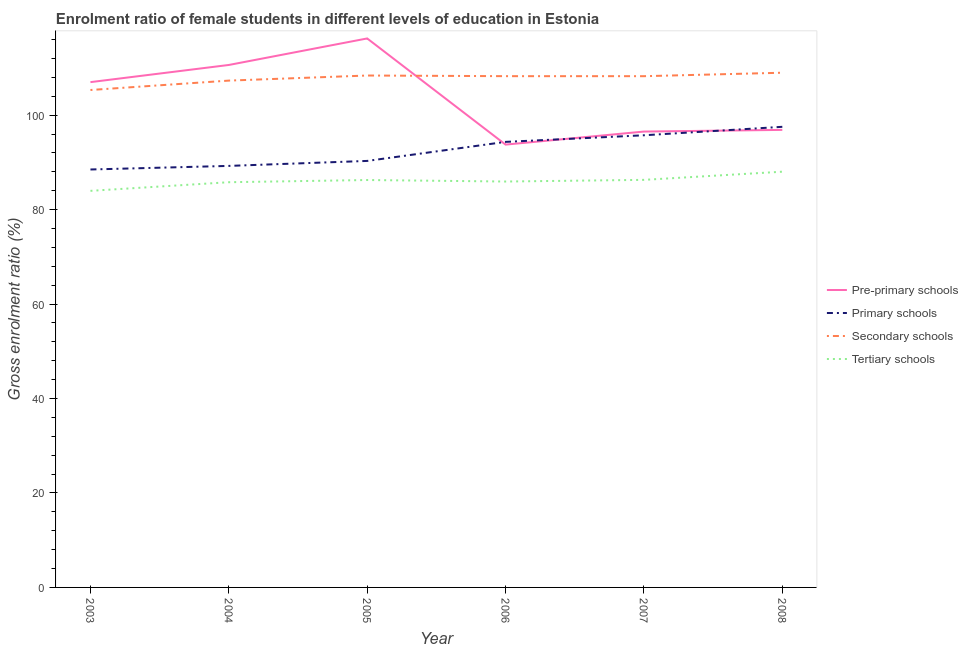How many different coloured lines are there?
Give a very brief answer. 4. Does the line corresponding to gross enrolment ratio(male) in secondary schools intersect with the line corresponding to gross enrolment ratio(male) in primary schools?
Offer a very short reply. No. What is the gross enrolment ratio(male) in pre-primary schools in 2005?
Give a very brief answer. 116.25. Across all years, what is the maximum gross enrolment ratio(male) in secondary schools?
Your response must be concise. 108.99. Across all years, what is the minimum gross enrolment ratio(male) in tertiary schools?
Your response must be concise. 83.98. What is the total gross enrolment ratio(male) in tertiary schools in the graph?
Offer a terse response. 516.35. What is the difference between the gross enrolment ratio(male) in secondary schools in 2005 and that in 2006?
Provide a succinct answer. 0.14. What is the difference between the gross enrolment ratio(male) in pre-primary schools in 2004 and the gross enrolment ratio(male) in tertiary schools in 2005?
Give a very brief answer. 24.36. What is the average gross enrolment ratio(male) in secondary schools per year?
Your answer should be very brief. 107.76. In the year 2003, what is the difference between the gross enrolment ratio(male) in tertiary schools and gross enrolment ratio(male) in primary schools?
Ensure brevity in your answer.  -4.52. In how many years, is the gross enrolment ratio(male) in pre-primary schools greater than 72 %?
Your answer should be very brief. 6. What is the ratio of the gross enrolment ratio(male) in primary schools in 2006 to that in 2007?
Provide a short and direct response. 0.99. What is the difference between the highest and the second highest gross enrolment ratio(male) in primary schools?
Your answer should be very brief. 1.79. What is the difference between the highest and the lowest gross enrolment ratio(male) in pre-primary schools?
Your answer should be very brief. 22.48. In how many years, is the gross enrolment ratio(male) in tertiary schools greater than the average gross enrolment ratio(male) in tertiary schools taken over all years?
Your answer should be very brief. 3. Is the sum of the gross enrolment ratio(male) in primary schools in 2004 and 2005 greater than the maximum gross enrolment ratio(male) in secondary schools across all years?
Ensure brevity in your answer.  Yes. Is it the case that in every year, the sum of the gross enrolment ratio(male) in primary schools and gross enrolment ratio(male) in tertiary schools is greater than the sum of gross enrolment ratio(male) in secondary schools and gross enrolment ratio(male) in pre-primary schools?
Provide a succinct answer. No. Does the gross enrolment ratio(male) in tertiary schools monotonically increase over the years?
Your answer should be compact. No. How many lines are there?
Ensure brevity in your answer.  4. What is the difference between two consecutive major ticks on the Y-axis?
Ensure brevity in your answer.  20. Are the values on the major ticks of Y-axis written in scientific E-notation?
Provide a short and direct response. No. Does the graph contain any zero values?
Provide a succinct answer. No. How many legend labels are there?
Provide a short and direct response. 4. What is the title of the graph?
Provide a short and direct response. Enrolment ratio of female students in different levels of education in Estonia. Does "Trade" appear as one of the legend labels in the graph?
Ensure brevity in your answer.  No. What is the label or title of the X-axis?
Give a very brief answer. Year. What is the Gross enrolment ratio (%) in Pre-primary schools in 2003?
Give a very brief answer. 107. What is the Gross enrolment ratio (%) in Primary schools in 2003?
Make the answer very short. 88.5. What is the Gross enrolment ratio (%) of Secondary schools in 2003?
Ensure brevity in your answer.  105.33. What is the Gross enrolment ratio (%) of Tertiary schools in 2003?
Keep it short and to the point. 83.98. What is the Gross enrolment ratio (%) of Pre-primary schools in 2004?
Your answer should be compact. 110.64. What is the Gross enrolment ratio (%) in Primary schools in 2004?
Keep it short and to the point. 89.26. What is the Gross enrolment ratio (%) in Secondary schools in 2004?
Your answer should be very brief. 107.32. What is the Gross enrolment ratio (%) of Tertiary schools in 2004?
Give a very brief answer. 85.81. What is the Gross enrolment ratio (%) in Pre-primary schools in 2005?
Offer a very short reply. 116.25. What is the Gross enrolment ratio (%) in Primary schools in 2005?
Provide a succinct answer. 90.32. What is the Gross enrolment ratio (%) of Secondary schools in 2005?
Give a very brief answer. 108.4. What is the Gross enrolment ratio (%) of Tertiary schools in 2005?
Offer a very short reply. 86.27. What is the Gross enrolment ratio (%) of Pre-primary schools in 2006?
Keep it short and to the point. 93.77. What is the Gross enrolment ratio (%) of Primary schools in 2006?
Provide a short and direct response. 94.35. What is the Gross enrolment ratio (%) of Secondary schools in 2006?
Your answer should be very brief. 108.26. What is the Gross enrolment ratio (%) of Tertiary schools in 2006?
Make the answer very short. 85.95. What is the Gross enrolment ratio (%) in Pre-primary schools in 2007?
Offer a terse response. 96.53. What is the Gross enrolment ratio (%) in Primary schools in 2007?
Make the answer very short. 95.75. What is the Gross enrolment ratio (%) of Secondary schools in 2007?
Your answer should be very brief. 108.26. What is the Gross enrolment ratio (%) in Tertiary schools in 2007?
Your answer should be very brief. 86.31. What is the Gross enrolment ratio (%) of Pre-primary schools in 2008?
Offer a very short reply. 96.89. What is the Gross enrolment ratio (%) in Primary schools in 2008?
Keep it short and to the point. 97.54. What is the Gross enrolment ratio (%) in Secondary schools in 2008?
Give a very brief answer. 108.99. What is the Gross enrolment ratio (%) in Tertiary schools in 2008?
Offer a terse response. 88.04. Across all years, what is the maximum Gross enrolment ratio (%) of Pre-primary schools?
Offer a terse response. 116.25. Across all years, what is the maximum Gross enrolment ratio (%) of Primary schools?
Provide a short and direct response. 97.54. Across all years, what is the maximum Gross enrolment ratio (%) of Secondary schools?
Offer a terse response. 108.99. Across all years, what is the maximum Gross enrolment ratio (%) of Tertiary schools?
Provide a succinct answer. 88.04. Across all years, what is the minimum Gross enrolment ratio (%) of Pre-primary schools?
Your response must be concise. 93.77. Across all years, what is the minimum Gross enrolment ratio (%) in Primary schools?
Provide a succinct answer. 88.5. Across all years, what is the minimum Gross enrolment ratio (%) in Secondary schools?
Provide a succinct answer. 105.33. Across all years, what is the minimum Gross enrolment ratio (%) in Tertiary schools?
Your answer should be very brief. 83.98. What is the total Gross enrolment ratio (%) in Pre-primary schools in the graph?
Keep it short and to the point. 621.08. What is the total Gross enrolment ratio (%) in Primary schools in the graph?
Your response must be concise. 555.71. What is the total Gross enrolment ratio (%) in Secondary schools in the graph?
Your response must be concise. 646.58. What is the total Gross enrolment ratio (%) in Tertiary schools in the graph?
Your answer should be compact. 516.35. What is the difference between the Gross enrolment ratio (%) in Pre-primary schools in 2003 and that in 2004?
Offer a terse response. -3.63. What is the difference between the Gross enrolment ratio (%) in Primary schools in 2003 and that in 2004?
Provide a succinct answer. -0.76. What is the difference between the Gross enrolment ratio (%) of Secondary schools in 2003 and that in 2004?
Provide a succinct answer. -1.99. What is the difference between the Gross enrolment ratio (%) of Tertiary schools in 2003 and that in 2004?
Make the answer very short. -1.83. What is the difference between the Gross enrolment ratio (%) of Pre-primary schools in 2003 and that in 2005?
Your answer should be compact. -9.25. What is the difference between the Gross enrolment ratio (%) of Primary schools in 2003 and that in 2005?
Your answer should be compact. -1.81. What is the difference between the Gross enrolment ratio (%) in Secondary schools in 2003 and that in 2005?
Your answer should be very brief. -3.07. What is the difference between the Gross enrolment ratio (%) in Tertiary schools in 2003 and that in 2005?
Give a very brief answer. -2.29. What is the difference between the Gross enrolment ratio (%) of Pre-primary schools in 2003 and that in 2006?
Make the answer very short. 13.23. What is the difference between the Gross enrolment ratio (%) in Primary schools in 2003 and that in 2006?
Your answer should be very brief. -5.85. What is the difference between the Gross enrolment ratio (%) in Secondary schools in 2003 and that in 2006?
Make the answer very short. -2.93. What is the difference between the Gross enrolment ratio (%) in Tertiary schools in 2003 and that in 2006?
Your answer should be compact. -1.97. What is the difference between the Gross enrolment ratio (%) in Pre-primary schools in 2003 and that in 2007?
Your response must be concise. 10.47. What is the difference between the Gross enrolment ratio (%) of Primary schools in 2003 and that in 2007?
Your response must be concise. -7.24. What is the difference between the Gross enrolment ratio (%) in Secondary schools in 2003 and that in 2007?
Make the answer very short. -2.93. What is the difference between the Gross enrolment ratio (%) in Tertiary schools in 2003 and that in 2007?
Your answer should be compact. -2.33. What is the difference between the Gross enrolment ratio (%) of Pre-primary schools in 2003 and that in 2008?
Provide a short and direct response. 10.11. What is the difference between the Gross enrolment ratio (%) in Primary schools in 2003 and that in 2008?
Offer a terse response. -9.04. What is the difference between the Gross enrolment ratio (%) of Secondary schools in 2003 and that in 2008?
Your answer should be compact. -3.66. What is the difference between the Gross enrolment ratio (%) of Tertiary schools in 2003 and that in 2008?
Your response must be concise. -4.06. What is the difference between the Gross enrolment ratio (%) in Pre-primary schools in 2004 and that in 2005?
Offer a terse response. -5.62. What is the difference between the Gross enrolment ratio (%) in Primary schools in 2004 and that in 2005?
Ensure brevity in your answer.  -1.05. What is the difference between the Gross enrolment ratio (%) in Secondary schools in 2004 and that in 2005?
Your answer should be very brief. -1.08. What is the difference between the Gross enrolment ratio (%) of Tertiary schools in 2004 and that in 2005?
Your answer should be compact. -0.47. What is the difference between the Gross enrolment ratio (%) in Pre-primary schools in 2004 and that in 2006?
Keep it short and to the point. 16.86. What is the difference between the Gross enrolment ratio (%) in Primary schools in 2004 and that in 2006?
Provide a short and direct response. -5.09. What is the difference between the Gross enrolment ratio (%) of Secondary schools in 2004 and that in 2006?
Ensure brevity in your answer.  -0.94. What is the difference between the Gross enrolment ratio (%) of Tertiary schools in 2004 and that in 2006?
Offer a terse response. -0.15. What is the difference between the Gross enrolment ratio (%) of Pre-primary schools in 2004 and that in 2007?
Make the answer very short. 14.1. What is the difference between the Gross enrolment ratio (%) of Primary schools in 2004 and that in 2007?
Keep it short and to the point. -6.49. What is the difference between the Gross enrolment ratio (%) in Secondary schools in 2004 and that in 2007?
Ensure brevity in your answer.  -0.94. What is the difference between the Gross enrolment ratio (%) of Tertiary schools in 2004 and that in 2007?
Make the answer very short. -0.5. What is the difference between the Gross enrolment ratio (%) of Pre-primary schools in 2004 and that in 2008?
Ensure brevity in your answer.  13.75. What is the difference between the Gross enrolment ratio (%) in Primary schools in 2004 and that in 2008?
Offer a terse response. -8.28. What is the difference between the Gross enrolment ratio (%) of Secondary schools in 2004 and that in 2008?
Keep it short and to the point. -1.67. What is the difference between the Gross enrolment ratio (%) of Tertiary schools in 2004 and that in 2008?
Ensure brevity in your answer.  -2.23. What is the difference between the Gross enrolment ratio (%) of Pre-primary schools in 2005 and that in 2006?
Provide a succinct answer. 22.48. What is the difference between the Gross enrolment ratio (%) in Primary schools in 2005 and that in 2006?
Ensure brevity in your answer.  -4.03. What is the difference between the Gross enrolment ratio (%) of Secondary schools in 2005 and that in 2006?
Your answer should be compact. 0.14. What is the difference between the Gross enrolment ratio (%) in Tertiary schools in 2005 and that in 2006?
Offer a very short reply. 0.32. What is the difference between the Gross enrolment ratio (%) of Pre-primary schools in 2005 and that in 2007?
Provide a succinct answer. 19.72. What is the difference between the Gross enrolment ratio (%) of Primary schools in 2005 and that in 2007?
Ensure brevity in your answer.  -5.43. What is the difference between the Gross enrolment ratio (%) of Secondary schools in 2005 and that in 2007?
Provide a short and direct response. 0.14. What is the difference between the Gross enrolment ratio (%) in Tertiary schools in 2005 and that in 2007?
Provide a succinct answer. -0.03. What is the difference between the Gross enrolment ratio (%) of Pre-primary schools in 2005 and that in 2008?
Your response must be concise. 19.36. What is the difference between the Gross enrolment ratio (%) in Primary schools in 2005 and that in 2008?
Give a very brief answer. -7.22. What is the difference between the Gross enrolment ratio (%) in Secondary schools in 2005 and that in 2008?
Your answer should be very brief. -0.59. What is the difference between the Gross enrolment ratio (%) in Tertiary schools in 2005 and that in 2008?
Give a very brief answer. -1.76. What is the difference between the Gross enrolment ratio (%) in Pre-primary schools in 2006 and that in 2007?
Your answer should be very brief. -2.76. What is the difference between the Gross enrolment ratio (%) in Primary schools in 2006 and that in 2007?
Ensure brevity in your answer.  -1.4. What is the difference between the Gross enrolment ratio (%) of Secondary schools in 2006 and that in 2007?
Your answer should be compact. 0. What is the difference between the Gross enrolment ratio (%) in Tertiary schools in 2006 and that in 2007?
Provide a succinct answer. -0.35. What is the difference between the Gross enrolment ratio (%) in Pre-primary schools in 2006 and that in 2008?
Give a very brief answer. -3.12. What is the difference between the Gross enrolment ratio (%) of Primary schools in 2006 and that in 2008?
Your answer should be very brief. -3.19. What is the difference between the Gross enrolment ratio (%) of Secondary schools in 2006 and that in 2008?
Make the answer very short. -0.73. What is the difference between the Gross enrolment ratio (%) of Tertiary schools in 2006 and that in 2008?
Give a very brief answer. -2.08. What is the difference between the Gross enrolment ratio (%) of Pre-primary schools in 2007 and that in 2008?
Keep it short and to the point. -0.35. What is the difference between the Gross enrolment ratio (%) in Primary schools in 2007 and that in 2008?
Your answer should be very brief. -1.79. What is the difference between the Gross enrolment ratio (%) of Secondary schools in 2007 and that in 2008?
Your response must be concise. -0.73. What is the difference between the Gross enrolment ratio (%) of Tertiary schools in 2007 and that in 2008?
Give a very brief answer. -1.73. What is the difference between the Gross enrolment ratio (%) of Pre-primary schools in 2003 and the Gross enrolment ratio (%) of Primary schools in 2004?
Your answer should be compact. 17.74. What is the difference between the Gross enrolment ratio (%) in Pre-primary schools in 2003 and the Gross enrolment ratio (%) in Secondary schools in 2004?
Provide a short and direct response. -0.32. What is the difference between the Gross enrolment ratio (%) of Pre-primary schools in 2003 and the Gross enrolment ratio (%) of Tertiary schools in 2004?
Provide a short and direct response. 21.2. What is the difference between the Gross enrolment ratio (%) in Primary schools in 2003 and the Gross enrolment ratio (%) in Secondary schools in 2004?
Make the answer very short. -18.82. What is the difference between the Gross enrolment ratio (%) of Primary schools in 2003 and the Gross enrolment ratio (%) of Tertiary schools in 2004?
Your answer should be compact. 2.7. What is the difference between the Gross enrolment ratio (%) of Secondary schools in 2003 and the Gross enrolment ratio (%) of Tertiary schools in 2004?
Your answer should be very brief. 19.53. What is the difference between the Gross enrolment ratio (%) of Pre-primary schools in 2003 and the Gross enrolment ratio (%) of Primary schools in 2005?
Offer a very short reply. 16.69. What is the difference between the Gross enrolment ratio (%) of Pre-primary schools in 2003 and the Gross enrolment ratio (%) of Secondary schools in 2005?
Provide a short and direct response. -1.4. What is the difference between the Gross enrolment ratio (%) of Pre-primary schools in 2003 and the Gross enrolment ratio (%) of Tertiary schools in 2005?
Offer a terse response. 20.73. What is the difference between the Gross enrolment ratio (%) of Primary schools in 2003 and the Gross enrolment ratio (%) of Secondary schools in 2005?
Ensure brevity in your answer.  -19.9. What is the difference between the Gross enrolment ratio (%) in Primary schools in 2003 and the Gross enrolment ratio (%) in Tertiary schools in 2005?
Offer a terse response. 2.23. What is the difference between the Gross enrolment ratio (%) of Secondary schools in 2003 and the Gross enrolment ratio (%) of Tertiary schools in 2005?
Your answer should be very brief. 19.06. What is the difference between the Gross enrolment ratio (%) in Pre-primary schools in 2003 and the Gross enrolment ratio (%) in Primary schools in 2006?
Give a very brief answer. 12.65. What is the difference between the Gross enrolment ratio (%) of Pre-primary schools in 2003 and the Gross enrolment ratio (%) of Secondary schools in 2006?
Ensure brevity in your answer.  -1.26. What is the difference between the Gross enrolment ratio (%) in Pre-primary schools in 2003 and the Gross enrolment ratio (%) in Tertiary schools in 2006?
Offer a terse response. 21.05. What is the difference between the Gross enrolment ratio (%) in Primary schools in 2003 and the Gross enrolment ratio (%) in Secondary schools in 2006?
Provide a short and direct response. -19.76. What is the difference between the Gross enrolment ratio (%) in Primary schools in 2003 and the Gross enrolment ratio (%) in Tertiary schools in 2006?
Make the answer very short. 2.55. What is the difference between the Gross enrolment ratio (%) in Secondary schools in 2003 and the Gross enrolment ratio (%) in Tertiary schools in 2006?
Offer a very short reply. 19.38. What is the difference between the Gross enrolment ratio (%) in Pre-primary schools in 2003 and the Gross enrolment ratio (%) in Primary schools in 2007?
Keep it short and to the point. 11.25. What is the difference between the Gross enrolment ratio (%) in Pre-primary schools in 2003 and the Gross enrolment ratio (%) in Secondary schools in 2007?
Provide a short and direct response. -1.26. What is the difference between the Gross enrolment ratio (%) of Pre-primary schools in 2003 and the Gross enrolment ratio (%) of Tertiary schools in 2007?
Your response must be concise. 20.7. What is the difference between the Gross enrolment ratio (%) of Primary schools in 2003 and the Gross enrolment ratio (%) of Secondary schools in 2007?
Your response must be concise. -19.76. What is the difference between the Gross enrolment ratio (%) in Primary schools in 2003 and the Gross enrolment ratio (%) in Tertiary schools in 2007?
Provide a succinct answer. 2.2. What is the difference between the Gross enrolment ratio (%) of Secondary schools in 2003 and the Gross enrolment ratio (%) of Tertiary schools in 2007?
Keep it short and to the point. 19.03. What is the difference between the Gross enrolment ratio (%) of Pre-primary schools in 2003 and the Gross enrolment ratio (%) of Primary schools in 2008?
Give a very brief answer. 9.46. What is the difference between the Gross enrolment ratio (%) in Pre-primary schools in 2003 and the Gross enrolment ratio (%) in Secondary schools in 2008?
Ensure brevity in your answer.  -1.99. What is the difference between the Gross enrolment ratio (%) of Pre-primary schools in 2003 and the Gross enrolment ratio (%) of Tertiary schools in 2008?
Your response must be concise. 18.97. What is the difference between the Gross enrolment ratio (%) in Primary schools in 2003 and the Gross enrolment ratio (%) in Secondary schools in 2008?
Offer a very short reply. -20.49. What is the difference between the Gross enrolment ratio (%) of Primary schools in 2003 and the Gross enrolment ratio (%) of Tertiary schools in 2008?
Provide a succinct answer. 0.47. What is the difference between the Gross enrolment ratio (%) of Secondary schools in 2003 and the Gross enrolment ratio (%) of Tertiary schools in 2008?
Keep it short and to the point. 17.3. What is the difference between the Gross enrolment ratio (%) of Pre-primary schools in 2004 and the Gross enrolment ratio (%) of Primary schools in 2005?
Provide a succinct answer. 20.32. What is the difference between the Gross enrolment ratio (%) in Pre-primary schools in 2004 and the Gross enrolment ratio (%) in Secondary schools in 2005?
Ensure brevity in your answer.  2.24. What is the difference between the Gross enrolment ratio (%) of Pre-primary schools in 2004 and the Gross enrolment ratio (%) of Tertiary schools in 2005?
Ensure brevity in your answer.  24.36. What is the difference between the Gross enrolment ratio (%) of Primary schools in 2004 and the Gross enrolment ratio (%) of Secondary schools in 2005?
Give a very brief answer. -19.14. What is the difference between the Gross enrolment ratio (%) of Primary schools in 2004 and the Gross enrolment ratio (%) of Tertiary schools in 2005?
Give a very brief answer. 2.99. What is the difference between the Gross enrolment ratio (%) of Secondary schools in 2004 and the Gross enrolment ratio (%) of Tertiary schools in 2005?
Keep it short and to the point. 21.05. What is the difference between the Gross enrolment ratio (%) in Pre-primary schools in 2004 and the Gross enrolment ratio (%) in Primary schools in 2006?
Keep it short and to the point. 16.29. What is the difference between the Gross enrolment ratio (%) in Pre-primary schools in 2004 and the Gross enrolment ratio (%) in Secondary schools in 2006?
Your response must be concise. 2.37. What is the difference between the Gross enrolment ratio (%) of Pre-primary schools in 2004 and the Gross enrolment ratio (%) of Tertiary schools in 2006?
Provide a short and direct response. 24.68. What is the difference between the Gross enrolment ratio (%) of Primary schools in 2004 and the Gross enrolment ratio (%) of Secondary schools in 2006?
Ensure brevity in your answer.  -19. What is the difference between the Gross enrolment ratio (%) in Primary schools in 2004 and the Gross enrolment ratio (%) in Tertiary schools in 2006?
Keep it short and to the point. 3.31. What is the difference between the Gross enrolment ratio (%) in Secondary schools in 2004 and the Gross enrolment ratio (%) in Tertiary schools in 2006?
Your response must be concise. 21.37. What is the difference between the Gross enrolment ratio (%) in Pre-primary schools in 2004 and the Gross enrolment ratio (%) in Primary schools in 2007?
Offer a terse response. 14.89. What is the difference between the Gross enrolment ratio (%) of Pre-primary schools in 2004 and the Gross enrolment ratio (%) of Secondary schools in 2007?
Provide a succinct answer. 2.37. What is the difference between the Gross enrolment ratio (%) of Pre-primary schools in 2004 and the Gross enrolment ratio (%) of Tertiary schools in 2007?
Your answer should be compact. 24.33. What is the difference between the Gross enrolment ratio (%) in Primary schools in 2004 and the Gross enrolment ratio (%) in Secondary schools in 2007?
Your response must be concise. -19. What is the difference between the Gross enrolment ratio (%) in Primary schools in 2004 and the Gross enrolment ratio (%) in Tertiary schools in 2007?
Ensure brevity in your answer.  2.96. What is the difference between the Gross enrolment ratio (%) of Secondary schools in 2004 and the Gross enrolment ratio (%) of Tertiary schools in 2007?
Your response must be concise. 21.02. What is the difference between the Gross enrolment ratio (%) in Pre-primary schools in 2004 and the Gross enrolment ratio (%) in Primary schools in 2008?
Offer a terse response. 13.1. What is the difference between the Gross enrolment ratio (%) of Pre-primary schools in 2004 and the Gross enrolment ratio (%) of Secondary schools in 2008?
Your response must be concise. 1.64. What is the difference between the Gross enrolment ratio (%) of Pre-primary schools in 2004 and the Gross enrolment ratio (%) of Tertiary schools in 2008?
Provide a succinct answer. 22.6. What is the difference between the Gross enrolment ratio (%) of Primary schools in 2004 and the Gross enrolment ratio (%) of Secondary schools in 2008?
Your answer should be compact. -19.73. What is the difference between the Gross enrolment ratio (%) in Primary schools in 2004 and the Gross enrolment ratio (%) in Tertiary schools in 2008?
Your answer should be very brief. 1.23. What is the difference between the Gross enrolment ratio (%) of Secondary schools in 2004 and the Gross enrolment ratio (%) of Tertiary schools in 2008?
Provide a short and direct response. 19.29. What is the difference between the Gross enrolment ratio (%) of Pre-primary schools in 2005 and the Gross enrolment ratio (%) of Primary schools in 2006?
Provide a succinct answer. 21.9. What is the difference between the Gross enrolment ratio (%) of Pre-primary schools in 2005 and the Gross enrolment ratio (%) of Secondary schools in 2006?
Your answer should be very brief. 7.99. What is the difference between the Gross enrolment ratio (%) of Pre-primary schools in 2005 and the Gross enrolment ratio (%) of Tertiary schools in 2006?
Offer a very short reply. 30.3. What is the difference between the Gross enrolment ratio (%) in Primary schools in 2005 and the Gross enrolment ratio (%) in Secondary schools in 2006?
Provide a short and direct response. -17.95. What is the difference between the Gross enrolment ratio (%) in Primary schools in 2005 and the Gross enrolment ratio (%) in Tertiary schools in 2006?
Make the answer very short. 4.36. What is the difference between the Gross enrolment ratio (%) in Secondary schools in 2005 and the Gross enrolment ratio (%) in Tertiary schools in 2006?
Offer a very short reply. 22.45. What is the difference between the Gross enrolment ratio (%) in Pre-primary schools in 2005 and the Gross enrolment ratio (%) in Primary schools in 2007?
Your response must be concise. 20.5. What is the difference between the Gross enrolment ratio (%) in Pre-primary schools in 2005 and the Gross enrolment ratio (%) in Secondary schools in 2007?
Your answer should be compact. 7.99. What is the difference between the Gross enrolment ratio (%) of Pre-primary schools in 2005 and the Gross enrolment ratio (%) of Tertiary schools in 2007?
Your response must be concise. 29.95. What is the difference between the Gross enrolment ratio (%) of Primary schools in 2005 and the Gross enrolment ratio (%) of Secondary schools in 2007?
Give a very brief answer. -17.94. What is the difference between the Gross enrolment ratio (%) in Primary schools in 2005 and the Gross enrolment ratio (%) in Tertiary schools in 2007?
Give a very brief answer. 4.01. What is the difference between the Gross enrolment ratio (%) in Secondary schools in 2005 and the Gross enrolment ratio (%) in Tertiary schools in 2007?
Your response must be concise. 22.09. What is the difference between the Gross enrolment ratio (%) in Pre-primary schools in 2005 and the Gross enrolment ratio (%) in Primary schools in 2008?
Your answer should be very brief. 18.71. What is the difference between the Gross enrolment ratio (%) of Pre-primary schools in 2005 and the Gross enrolment ratio (%) of Secondary schools in 2008?
Offer a terse response. 7.26. What is the difference between the Gross enrolment ratio (%) of Pre-primary schools in 2005 and the Gross enrolment ratio (%) of Tertiary schools in 2008?
Provide a short and direct response. 28.22. What is the difference between the Gross enrolment ratio (%) in Primary schools in 2005 and the Gross enrolment ratio (%) in Secondary schools in 2008?
Give a very brief answer. -18.68. What is the difference between the Gross enrolment ratio (%) in Primary schools in 2005 and the Gross enrolment ratio (%) in Tertiary schools in 2008?
Offer a very short reply. 2.28. What is the difference between the Gross enrolment ratio (%) of Secondary schools in 2005 and the Gross enrolment ratio (%) of Tertiary schools in 2008?
Give a very brief answer. 20.36. What is the difference between the Gross enrolment ratio (%) of Pre-primary schools in 2006 and the Gross enrolment ratio (%) of Primary schools in 2007?
Offer a terse response. -1.98. What is the difference between the Gross enrolment ratio (%) of Pre-primary schools in 2006 and the Gross enrolment ratio (%) of Secondary schools in 2007?
Your answer should be very brief. -14.49. What is the difference between the Gross enrolment ratio (%) in Pre-primary schools in 2006 and the Gross enrolment ratio (%) in Tertiary schools in 2007?
Give a very brief answer. 7.46. What is the difference between the Gross enrolment ratio (%) in Primary schools in 2006 and the Gross enrolment ratio (%) in Secondary schools in 2007?
Ensure brevity in your answer.  -13.91. What is the difference between the Gross enrolment ratio (%) of Primary schools in 2006 and the Gross enrolment ratio (%) of Tertiary schools in 2007?
Provide a short and direct response. 8.04. What is the difference between the Gross enrolment ratio (%) of Secondary schools in 2006 and the Gross enrolment ratio (%) of Tertiary schools in 2007?
Provide a short and direct response. 21.96. What is the difference between the Gross enrolment ratio (%) in Pre-primary schools in 2006 and the Gross enrolment ratio (%) in Primary schools in 2008?
Ensure brevity in your answer.  -3.77. What is the difference between the Gross enrolment ratio (%) of Pre-primary schools in 2006 and the Gross enrolment ratio (%) of Secondary schools in 2008?
Offer a terse response. -15.22. What is the difference between the Gross enrolment ratio (%) in Pre-primary schools in 2006 and the Gross enrolment ratio (%) in Tertiary schools in 2008?
Provide a succinct answer. 5.73. What is the difference between the Gross enrolment ratio (%) of Primary schools in 2006 and the Gross enrolment ratio (%) of Secondary schools in 2008?
Provide a short and direct response. -14.64. What is the difference between the Gross enrolment ratio (%) of Primary schools in 2006 and the Gross enrolment ratio (%) of Tertiary schools in 2008?
Offer a very short reply. 6.31. What is the difference between the Gross enrolment ratio (%) in Secondary schools in 2006 and the Gross enrolment ratio (%) in Tertiary schools in 2008?
Keep it short and to the point. 20.23. What is the difference between the Gross enrolment ratio (%) in Pre-primary schools in 2007 and the Gross enrolment ratio (%) in Primary schools in 2008?
Keep it short and to the point. -1.01. What is the difference between the Gross enrolment ratio (%) of Pre-primary schools in 2007 and the Gross enrolment ratio (%) of Secondary schools in 2008?
Your answer should be compact. -12.46. What is the difference between the Gross enrolment ratio (%) in Pre-primary schools in 2007 and the Gross enrolment ratio (%) in Tertiary schools in 2008?
Keep it short and to the point. 8.5. What is the difference between the Gross enrolment ratio (%) in Primary schools in 2007 and the Gross enrolment ratio (%) in Secondary schools in 2008?
Provide a short and direct response. -13.25. What is the difference between the Gross enrolment ratio (%) in Primary schools in 2007 and the Gross enrolment ratio (%) in Tertiary schools in 2008?
Your answer should be compact. 7.71. What is the difference between the Gross enrolment ratio (%) of Secondary schools in 2007 and the Gross enrolment ratio (%) of Tertiary schools in 2008?
Provide a succinct answer. 20.23. What is the average Gross enrolment ratio (%) in Pre-primary schools per year?
Your response must be concise. 103.51. What is the average Gross enrolment ratio (%) in Primary schools per year?
Ensure brevity in your answer.  92.62. What is the average Gross enrolment ratio (%) of Secondary schools per year?
Provide a succinct answer. 107.76. What is the average Gross enrolment ratio (%) in Tertiary schools per year?
Your answer should be compact. 86.06. In the year 2003, what is the difference between the Gross enrolment ratio (%) of Pre-primary schools and Gross enrolment ratio (%) of Primary schools?
Offer a very short reply. 18.5. In the year 2003, what is the difference between the Gross enrolment ratio (%) in Pre-primary schools and Gross enrolment ratio (%) in Secondary schools?
Offer a very short reply. 1.67. In the year 2003, what is the difference between the Gross enrolment ratio (%) in Pre-primary schools and Gross enrolment ratio (%) in Tertiary schools?
Your answer should be very brief. 23.02. In the year 2003, what is the difference between the Gross enrolment ratio (%) of Primary schools and Gross enrolment ratio (%) of Secondary schools?
Your response must be concise. -16.83. In the year 2003, what is the difference between the Gross enrolment ratio (%) in Primary schools and Gross enrolment ratio (%) in Tertiary schools?
Provide a succinct answer. 4.52. In the year 2003, what is the difference between the Gross enrolment ratio (%) in Secondary schools and Gross enrolment ratio (%) in Tertiary schools?
Provide a short and direct response. 21.36. In the year 2004, what is the difference between the Gross enrolment ratio (%) in Pre-primary schools and Gross enrolment ratio (%) in Primary schools?
Provide a succinct answer. 21.37. In the year 2004, what is the difference between the Gross enrolment ratio (%) of Pre-primary schools and Gross enrolment ratio (%) of Secondary schools?
Offer a terse response. 3.31. In the year 2004, what is the difference between the Gross enrolment ratio (%) of Pre-primary schools and Gross enrolment ratio (%) of Tertiary schools?
Give a very brief answer. 24.83. In the year 2004, what is the difference between the Gross enrolment ratio (%) of Primary schools and Gross enrolment ratio (%) of Secondary schools?
Offer a very short reply. -18.06. In the year 2004, what is the difference between the Gross enrolment ratio (%) of Primary schools and Gross enrolment ratio (%) of Tertiary schools?
Give a very brief answer. 3.45. In the year 2004, what is the difference between the Gross enrolment ratio (%) in Secondary schools and Gross enrolment ratio (%) in Tertiary schools?
Offer a very short reply. 21.52. In the year 2005, what is the difference between the Gross enrolment ratio (%) in Pre-primary schools and Gross enrolment ratio (%) in Primary schools?
Your answer should be compact. 25.94. In the year 2005, what is the difference between the Gross enrolment ratio (%) in Pre-primary schools and Gross enrolment ratio (%) in Secondary schools?
Offer a terse response. 7.85. In the year 2005, what is the difference between the Gross enrolment ratio (%) of Pre-primary schools and Gross enrolment ratio (%) of Tertiary schools?
Offer a terse response. 29.98. In the year 2005, what is the difference between the Gross enrolment ratio (%) of Primary schools and Gross enrolment ratio (%) of Secondary schools?
Give a very brief answer. -18.08. In the year 2005, what is the difference between the Gross enrolment ratio (%) of Primary schools and Gross enrolment ratio (%) of Tertiary schools?
Make the answer very short. 4.04. In the year 2005, what is the difference between the Gross enrolment ratio (%) in Secondary schools and Gross enrolment ratio (%) in Tertiary schools?
Give a very brief answer. 22.13. In the year 2006, what is the difference between the Gross enrolment ratio (%) in Pre-primary schools and Gross enrolment ratio (%) in Primary schools?
Ensure brevity in your answer.  -0.58. In the year 2006, what is the difference between the Gross enrolment ratio (%) in Pre-primary schools and Gross enrolment ratio (%) in Secondary schools?
Make the answer very short. -14.49. In the year 2006, what is the difference between the Gross enrolment ratio (%) of Pre-primary schools and Gross enrolment ratio (%) of Tertiary schools?
Keep it short and to the point. 7.82. In the year 2006, what is the difference between the Gross enrolment ratio (%) of Primary schools and Gross enrolment ratio (%) of Secondary schools?
Provide a succinct answer. -13.92. In the year 2006, what is the difference between the Gross enrolment ratio (%) of Primary schools and Gross enrolment ratio (%) of Tertiary schools?
Provide a short and direct response. 8.4. In the year 2006, what is the difference between the Gross enrolment ratio (%) of Secondary schools and Gross enrolment ratio (%) of Tertiary schools?
Your response must be concise. 22.31. In the year 2007, what is the difference between the Gross enrolment ratio (%) in Pre-primary schools and Gross enrolment ratio (%) in Primary schools?
Your answer should be compact. 0.79. In the year 2007, what is the difference between the Gross enrolment ratio (%) of Pre-primary schools and Gross enrolment ratio (%) of Secondary schools?
Provide a short and direct response. -11.73. In the year 2007, what is the difference between the Gross enrolment ratio (%) in Pre-primary schools and Gross enrolment ratio (%) in Tertiary schools?
Give a very brief answer. 10.23. In the year 2007, what is the difference between the Gross enrolment ratio (%) in Primary schools and Gross enrolment ratio (%) in Secondary schools?
Make the answer very short. -12.51. In the year 2007, what is the difference between the Gross enrolment ratio (%) of Primary schools and Gross enrolment ratio (%) of Tertiary schools?
Ensure brevity in your answer.  9.44. In the year 2007, what is the difference between the Gross enrolment ratio (%) of Secondary schools and Gross enrolment ratio (%) of Tertiary schools?
Your answer should be compact. 21.96. In the year 2008, what is the difference between the Gross enrolment ratio (%) in Pre-primary schools and Gross enrolment ratio (%) in Primary schools?
Give a very brief answer. -0.65. In the year 2008, what is the difference between the Gross enrolment ratio (%) in Pre-primary schools and Gross enrolment ratio (%) in Secondary schools?
Your response must be concise. -12.11. In the year 2008, what is the difference between the Gross enrolment ratio (%) in Pre-primary schools and Gross enrolment ratio (%) in Tertiary schools?
Give a very brief answer. 8.85. In the year 2008, what is the difference between the Gross enrolment ratio (%) in Primary schools and Gross enrolment ratio (%) in Secondary schools?
Make the answer very short. -11.45. In the year 2008, what is the difference between the Gross enrolment ratio (%) of Primary schools and Gross enrolment ratio (%) of Tertiary schools?
Offer a terse response. 9.5. In the year 2008, what is the difference between the Gross enrolment ratio (%) in Secondary schools and Gross enrolment ratio (%) in Tertiary schools?
Your response must be concise. 20.96. What is the ratio of the Gross enrolment ratio (%) in Pre-primary schools in 2003 to that in 2004?
Your response must be concise. 0.97. What is the ratio of the Gross enrolment ratio (%) of Primary schools in 2003 to that in 2004?
Offer a very short reply. 0.99. What is the ratio of the Gross enrolment ratio (%) in Secondary schools in 2003 to that in 2004?
Provide a short and direct response. 0.98. What is the ratio of the Gross enrolment ratio (%) in Tertiary schools in 2003 to that in 2004?
Offer a terse response. 0.98. What is the ratio of the Gross enrolment ratio (%) in Pre-primary schools in 2003 to that in 2005?
Give a very brief answer. 0.92. What is the ratio of the Gross enrolment ratio (%) of Primary schools in 2003 to that in 2005?
Your answer should be compact. 0.98. What is the ratio of the Gross enrolment ratio (%) in Secondary schools in 2003 to that in 2005?
Make the answer very short. 0.97. What is the ratio of the Gross enrolment ratio (%) in Tertiary schools in 2003 to that in 2005?
Offer a terse response. 0.97. What is the ratio of the Gross enrolment ratio (%) in Pre-primary schools in 2003 to that in 2006?
Give a very brief answer. 1.14. What is the ratio of the Gross enrolment ratio (%) of Primary schools in 2003 to that in 2006?
Offer a very short reply. 0.94. What is the ratio of the Gross enrolment ratio (%) of Secondary schools in 2003 to that in 2006?
Keep it short and to the point. 0.97. What is the ratio of the Gross enrolment ratio (%) of Pre-primary schools in 2003 to that in 2007?
Provide a succinct answer. 1.11. What is the ratio of the Gross enrolment ratio (%) of Primary schools in 2003 to that in 2007?
Your answer should be compact. 0.92. What is the ratio of the Gross enrolment ratio (%) in Secondary schools in 2003 to that in 2007?
Give a very brief answer. 0.97. What is the ratio of the Gross enrolment ratio (%) in Tertiary schools in 2003 to that in 2007?
Your response must be concise. 0.97. What is the ratio of the Gross enrolment ratio (%) of Pre-primary schools in 2003 to that in 2008?
Give a very brief answer. 1.1. What is the ratio of the Gross enrolment ratio (%) in Primary schools in 2003 to that in 2008?
Offer a very short reply. 0.91. What is the ratio of the Gross enrolment ratio (%) of Secondary schools in 2003 to that in 2008?
Your answer should be compact. 0.97. What is the ratio of the Gross enrolment ratio (%) in Tertiary schools in 2003 to that in 2008?
Your answer should be compact. 0.95. What is the ratio of the Gross enrolment ratio (%) in Pre-primary schools in 2004 to that in 2005?
Your response must be concise. 0.95. What is the ratio of the Gross enrolment ratio (%) in Primary schools in 2004 to that in 2005?
Provide a succinct answer. 0.99. What is the ratio of the Gross enrolment ratio (%) of Tertiary schools in 2004 to that in 2005?
Keep it short and to the point. 0.99. What is the ratio of the Gross enrolment ratio (%) of Pre-primary schools in 2004 to that in 2006?
Provide a succinct answer. 1.18. What is the ratio of the Gross enrolment ratio (%) of Primary schools in 2004 to that in 2006?
Ensure brevity in your answer.  0.95. What is the ratio of the Gross enrolment ratio (%) in Secondary schools in 2004 to that in 2006?
Make the answer very short. 0.99. What is the ratio of the Gross enrolment ratio (%) of Pre-primary schools in 2004 to that in 2007?
Keep it short and to the point. 1.15. What is the ratio of the Gross enrolment ratio (%) in Primary schools in 2004 to that in 2007?
Your response must be concise. 0.93. What is the ratio of the Gross enrolment ratio (%) in Tertiary schools in 2004 to that in 2007?
Provide a short and direct response. 0.99. What is the ratio of the Gross enrolment ratio (%) of Pre-primary schools in 2004 to that in 2008?
Keep it short and to the point. 1.14. What is the ratio of the Gross enrolment ratio (%) of Primary schools in 2004 to that in 2008?
Make the answer very short. 0.92. What is the ratio of the Gross enrolment ratio (%) in Secondary schools in 2004 to that in 2008?
Keep it short and to the point. 0.98. What is the ratio of the Gross enrolment ratio (%) of Tertiary schools in 2004 to that in 2008?
Offer a terse response. 0.97. What is the ratio of the Gross enrolment ratio (%) in Pre-primary schools in 2005 to that in 2006?
Offer a very short reply. 1.24. What is the ratio of the Gross enrolment ratio (%) of Primary schools in 2005 to that in 2006?
Ensure brevity in your answer.  0.96. What is the ratio of the Gross enrolment ratio (%) of Secondary schools in 2005 to that in 2006?
Your response must be concise. 1. What is the ratio of the Gross enrolment ratio (%) in Pre-primary schools in 2005 to that in 2007?
Make the answer very short. 1.2. What is the ratio of the Gross enrolment ratio (%) of Primary schools in 2005 to that in 2007?
Make the answer very short. 0.94. What is the ratio of the Gross enrolment ratio (%) in Secondary schools in 2005 to that in 2007?
Offer a terse response. 1. What is the ratio of the Gross enrolment ratio (%) in Pre-primary schools in 2005 to that in 2008?
Your response must be concise. 1.2. What is the ratio of the Gross enrolment ratio (%) in Primary schools in 2005 to that in 2008?
Keep it short and to the point. 0.93. What is the ratio of the Gross enrolment ratio (%) of Secondary schools in 2005 to that in 2008?
Your answer should be compact. 0.99. What is the ratio of the Gross enrolment ratio (%) of Pre-primary schools in 2006 to that in 2007?
Keep it short and to the point. 0.97. What is the ratio of the Gross enrolment ratio (%) of Primary schools in 2006 to that in 2007?
Keep it short and to the point. 0.99. What is the ratio of the Gross enrolment ratio (%) of Tertiary schools in 2006 to that in 2007?
Your answer should be compact. 1. What is the ratio of the Gross enrolment ratio (%) of Pre-primary schools in 2006 to that in 2008?
Your response must be concise. 0.97. What is the ratio of the Gross enrolment ratio (%) in Primary schools in 2006 to that in 2008?
Offer a very short reply. 0.97. What is the ratio of the Gross enrolment ratio (%) in Tertiary schools in 2006 to that in 2008?
Provide a short and direct response. 0.98. What is the ratio of the Gross enrolment ratio (%) in Pre-primary schools in 2007 to that in 2008?
Make the answer very short. 1. What is the ratio of the Gross enrolment ratio (%) in Primary schools in 2007 to that in 2008?
Your answer should be compact. 0.98. What is the ratio of the Gross enrolment ratio (%) of Secondary schools in 2007 to that in 2008?
Keep it short and to the point. 0.99. What is the ratio of the Gross enrolment ratio (%) in Tertiary schools in 2007 to that in 2008?
Provide a short and direct response. 0.98. What is the difference between the highest and the second highest Gross enrolment ratio (%) in Pre-primary schools?
Make the answer very short. 5.62. What is the difference between the highest and the second highest Gross enrolment ratio (%) of Primary schools?
Provide a short and direct response. 1.79. What is the difference between the highest and the second highest Gross enrolment ratio (%) in Secondary schools?
Make the answer very short. 0.59. What is the difference between the highest and the second highest Gross enrolment ratio (%) of Tertiary schools?
Make the answer very short. 1.73. What is the difference between the highest and the lowest Gross enrolment ratio (%) in Pre-primary schools?
Offer a very short reply. 22.48. What is the difference between the highest and the lowest Gross enrolment ratio (%) of Primary schools?
Keep it short and to the point. 9.04. What is the difference between the highest and the lowest Gross enrolment ratio (%) of Secondary schools?
Your answer should be very brief. 3.66. What is the difference between the highest and the lowest Gross enrolment ratio (%) in Tertiary schools?
Your answer should be compact. 4.06. 